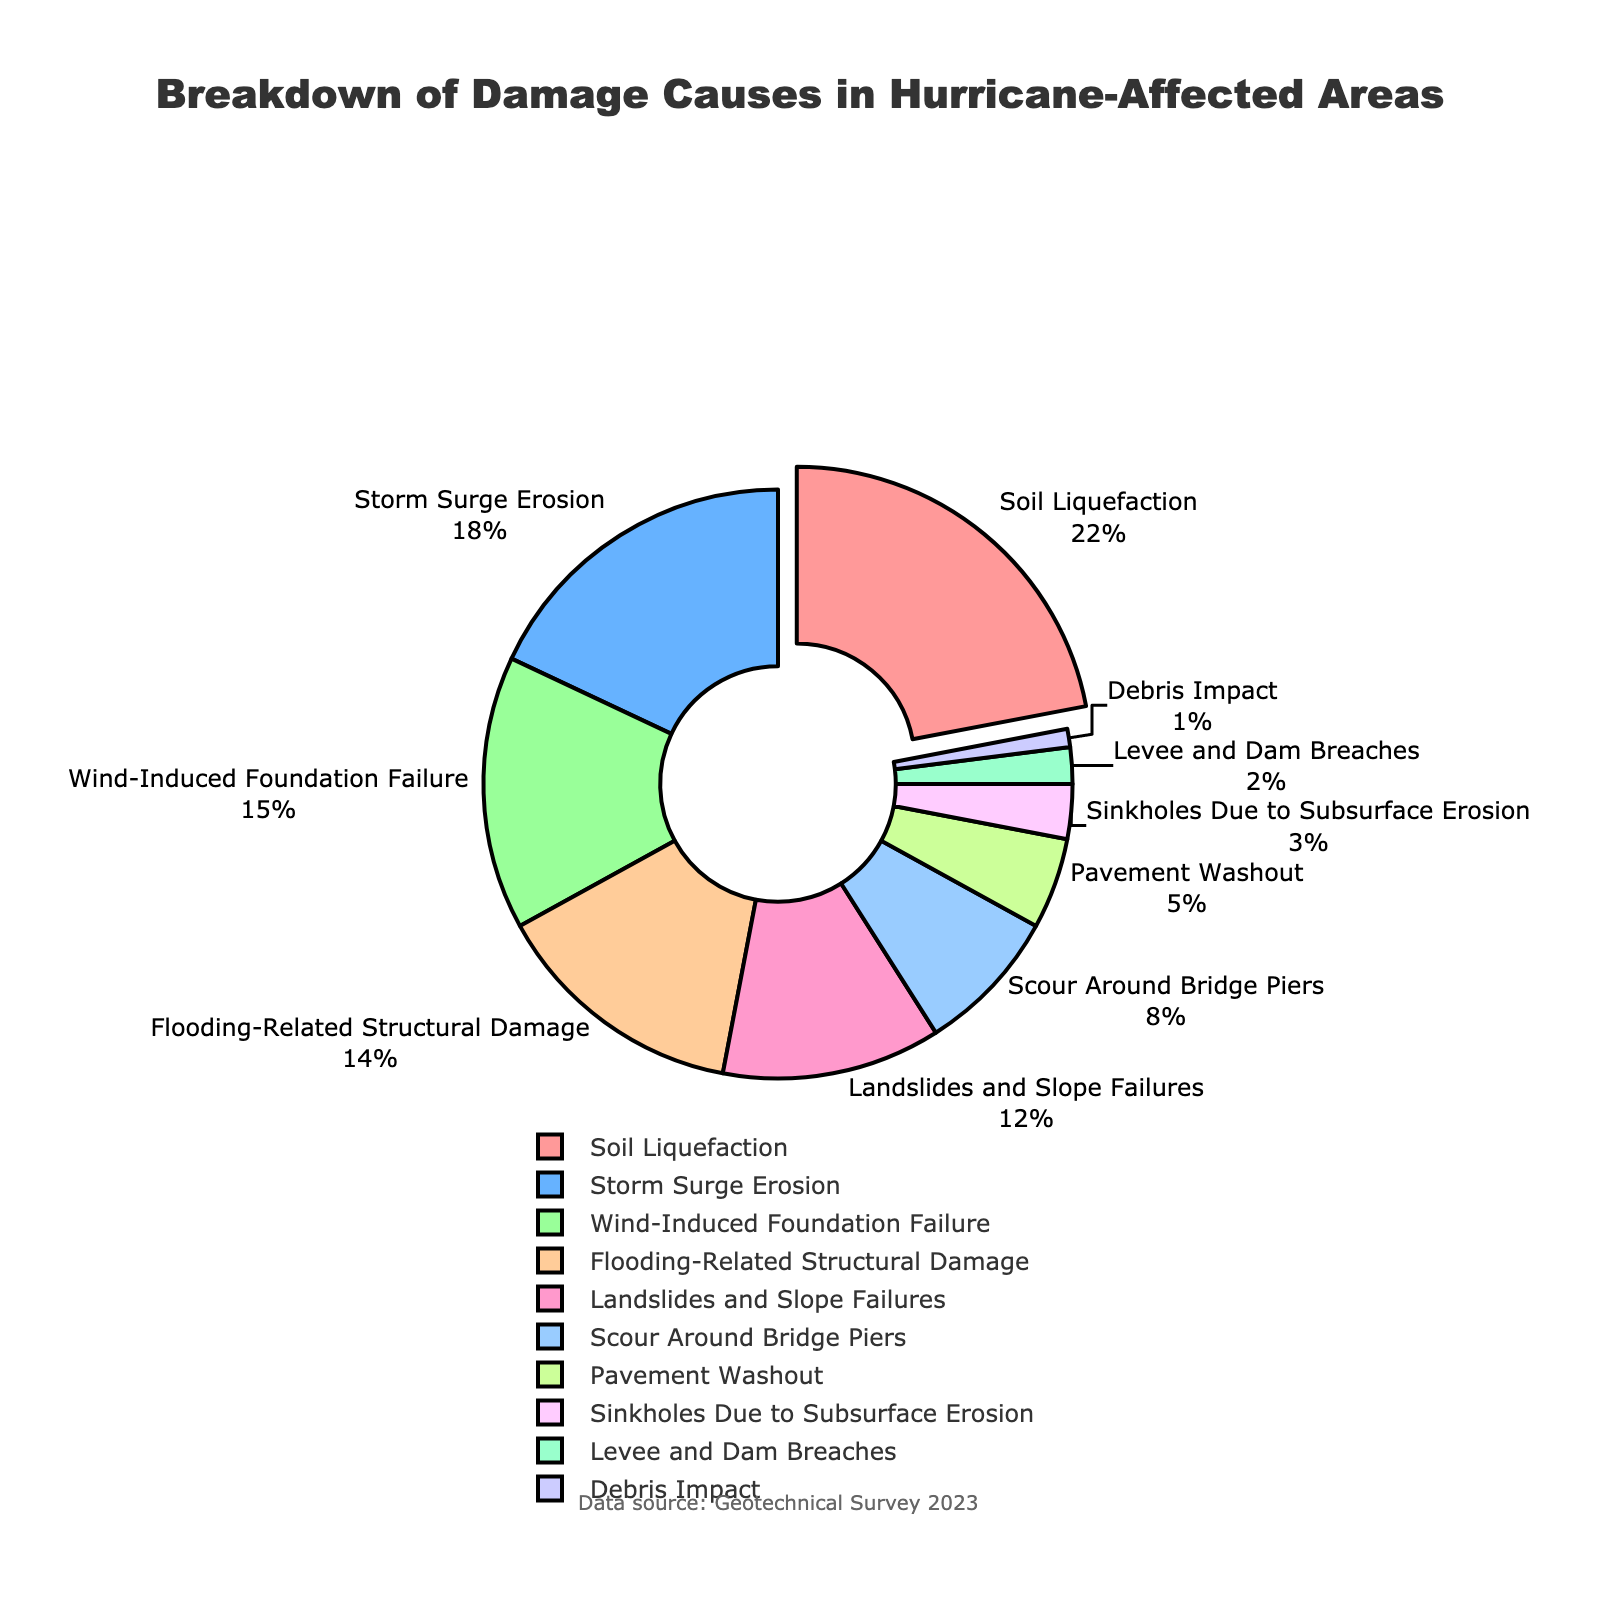What's the largest cause of damage to infrastructure in hurricane-affected areas? The figure shows that the segment with the highest percentage is "Soil Liquefaction" at 22%.
Answer: Soil Liquefaction What's the cumulative percentage of damage causes due to flooding-related structural damage, landslides and slope failures, and scour around bridge piers? Add the percentages of "Flooding-Related Structural Damage" (14%), "Landslides and Slope Failures" (12%), and "Scour Around Bridge Piers" (8%). So, 14% + 12% + 8% = 34%.
Answer: 34% Is the percentage of damage caused by wind-induced foundation failure greater or less than that caused by storm surge erosion? The figure indicates the percentage for "Wind-Induced Foundation Failure" is 15%, and for "Storm Surge Erosion" it is 18%. 15% is less than 18%.
Answer: Less What's the smallest cause of damage to infrastructure in hurricane-affected areas? According to the figure, the segment with the smallest percentage is "Debris Impact" at 1%.
Answer: Debris Impact What's the difference in the percentage of damage between soil liquefaction and sinkholes due to subsurface erosion? The figure shows "Soil Liquefaction" at 22% and "Sinkholes Due to Subsurface Erosion" at 3%. So, 22% - 3% = 19%.
Answer: 19% Which damage causes have a percentage greater than or equal to 10%? The figure indicates the categories with percentages greater than or equal to 10% are "Soil Liquefaction" (22%), "Storm Surge Erosion" (18%), "Wind-Induced Foundation Failure" (15%), and "Flooding-Related Structural Damage" (14%), "Landslides and Slope Failures" (12%).
Answer: Soil Liquefaction, Storm Surge Erosion, Wind-Induced Foundation Failure, Flooding-Related Structural Damage, Landslides and Slope Failures What percentage of damage is caused by pavement washout compared to the total sum of sinkholes due to subsurface erosion and levee and dam breaches? The percentage for "Pavement Washout" is 5%, while the combined percentage for "Sinkholes Due to Subsurface Erosion" (3%) and "Levee and Dam Breaches" (2%) is 3% + 2% = 5%. Therefore, both percentages are equal.
Answer: Equal How does the visual representation emphasize the major cause of damage? The figure visually highlights the "Soil Liquefaction" slice by pulling it out from the rest of the pie and shows it in a noticeable color.
Answer: Larger and pulled out slice What percentage of damage causes have less than 5% impact? The categories with less than 5% are "Sinkholes Due to Subsurface Erosion" (3%), "Levee and Dam Breaches" (2%), and "Debris Impact" (1%). Adding these gives 3% + 2% + 1% = 6%.
Answer: 6% 